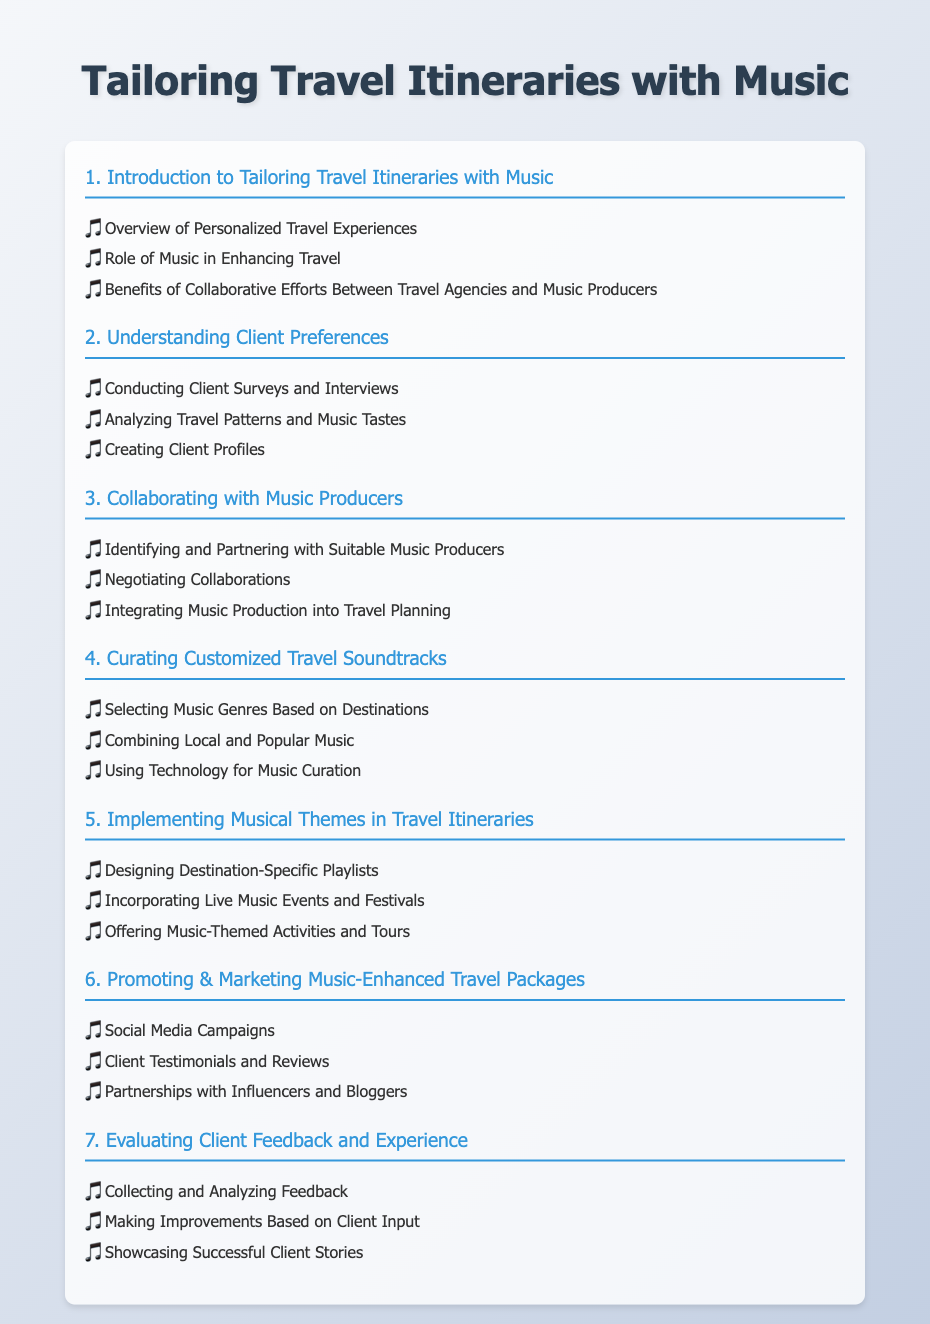What is the title of the document? The title is stated at the top of the rendered document.
Answer: Tailoring Travel Itineraries with Music What section discusses client preferences? The section is indicated by its number in the table of contents.
Answer: Understanding Client Preferences How many subsections are in the section about collaborating with music producers? The number of subsections is listed under the section title.
Answer: 3 Which theme is included for travel itineraries? The theme is a type of inclusion highlighted in the fifth section of the document.
Answer: Musical Themes What is one method mentioned for promoting music-enhanced travel packages? The methods are listed in the marketing section.
Answer: Social Media Campaigns How many total main sections are in the document? The total number of sections is reflected in the table of contents.
Answer: 7 